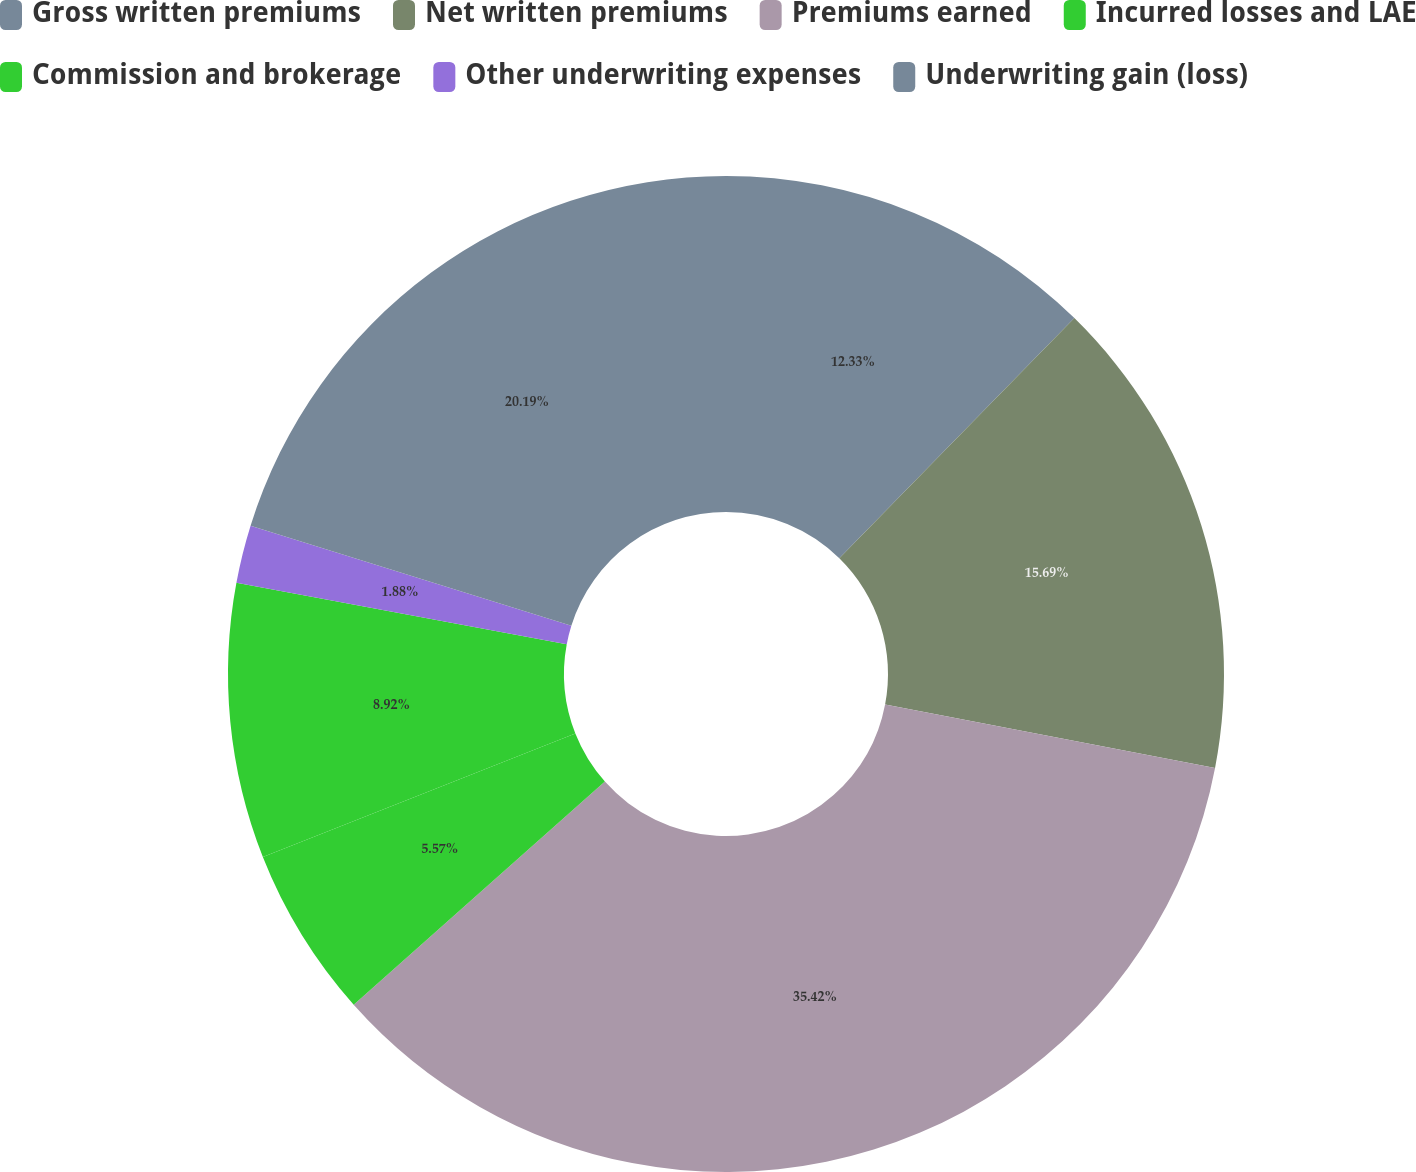Convert chart. <chart><loc_0><loc_0><loc_500><loc_500><pie_chart><fcel>Gross written premiums<fcel>Net written premiums<fcel>Premiums earned<fcel>Incurred losses and LAE<fcel>Commission and brokerage<fcel>Other underwriting expenses<fcel>Underwriting gain (loss)<nl><fcel>12.33%<fcel>15.69%<fcel>35.42%<fcel>5.57%<fcel>8.92%<fcel>1.88%<fcel>20.19%<nl></chart> 